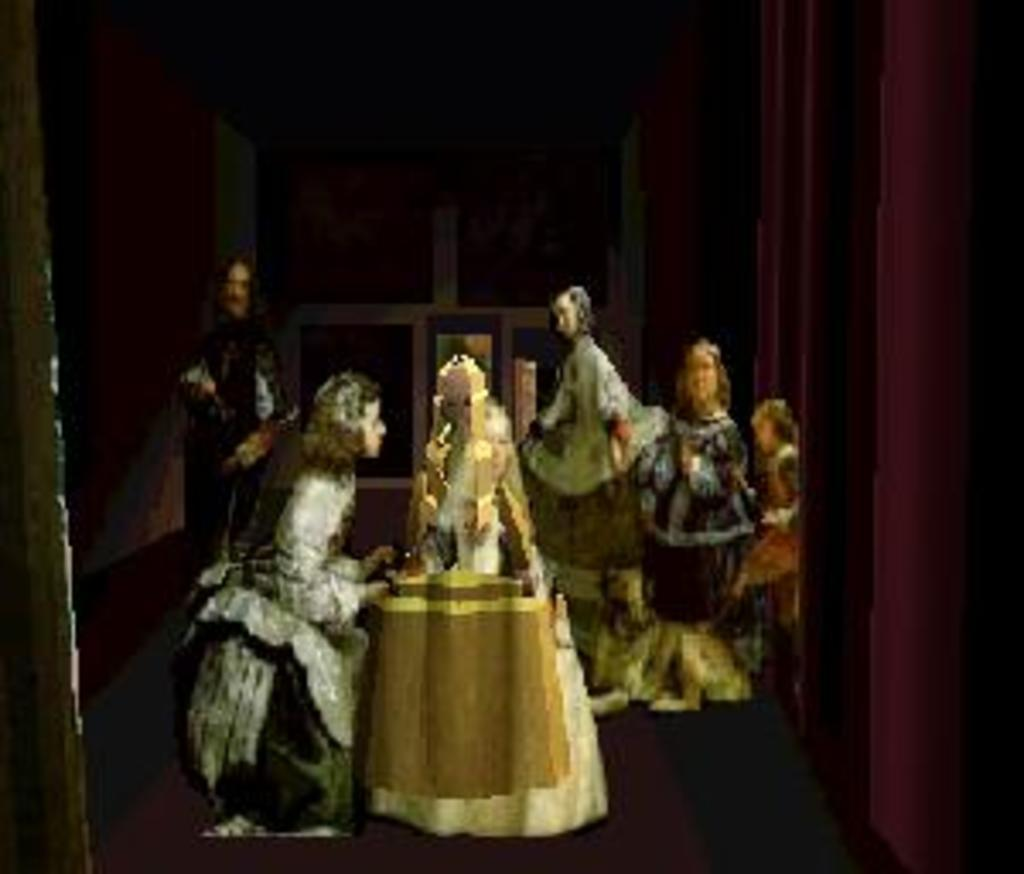What is the main feature of the image? The image contains a frame. What is depicted within the frame? The frame depicts persons. What is visible at the bottom of the image? There is a floor at the bottom of the image. How would you describe the overall lighting in the image? The background of the image is dark. Can you see any board games being played by the persons in the image? There is no board game visible in the image; it only depicts persons. Is there a squirrel present in the image? There is no squirrel present in the image; it only depicts persons. 